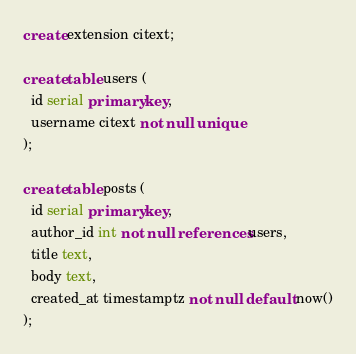Convert code to text. <code><loc_0><loc_0><loc_500><loc_500><_SQL_>create extension citext;

create table users (
  id serial primary key,
  username citext not null unique
);

create table posts (
  id serial primary key,
  author_id int not null references users,
  title text,
  body text,
  created_at timestamptz not null default now()
);</code> 